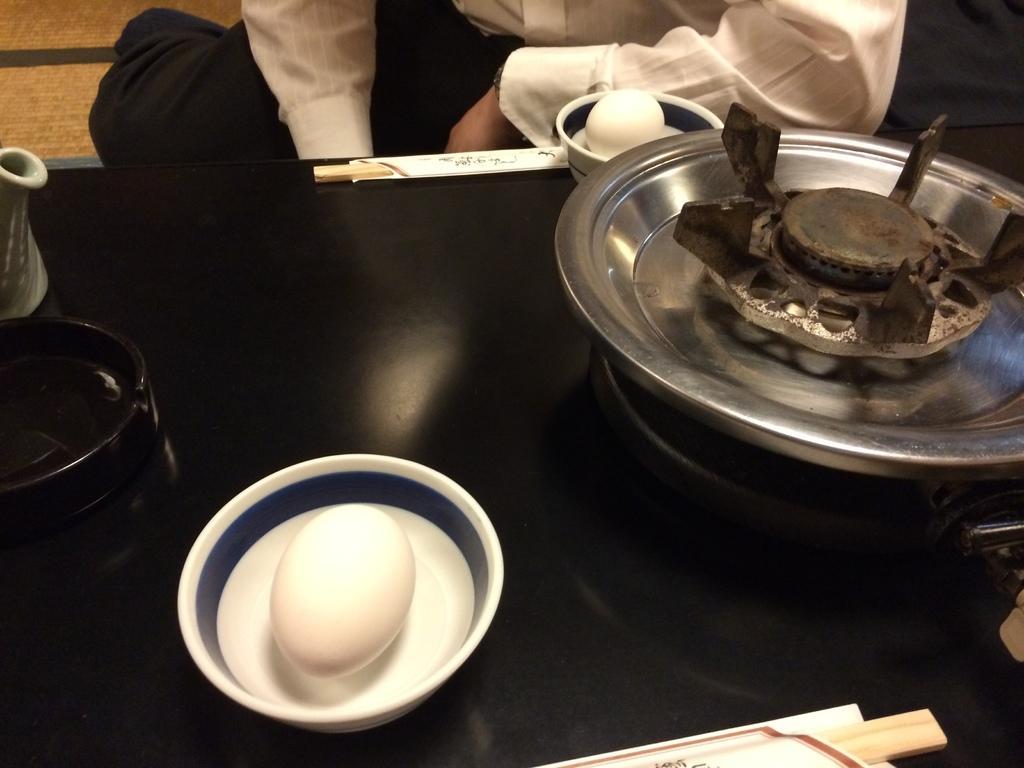Can you describe this image briefly? In this image I can see few eggs in bowls and few object something black color table. Back I can see a person wearing white and black dress. 